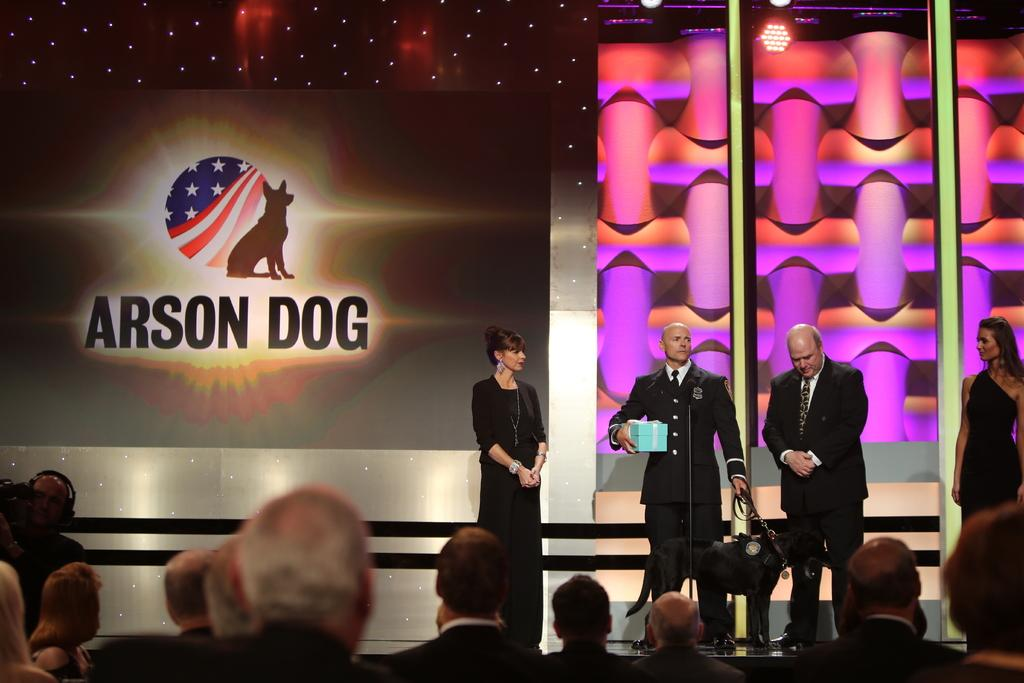<image>
Write a terse but informative summary of the picture. Four people are on stage in front of a wall that says Arson Dog. 